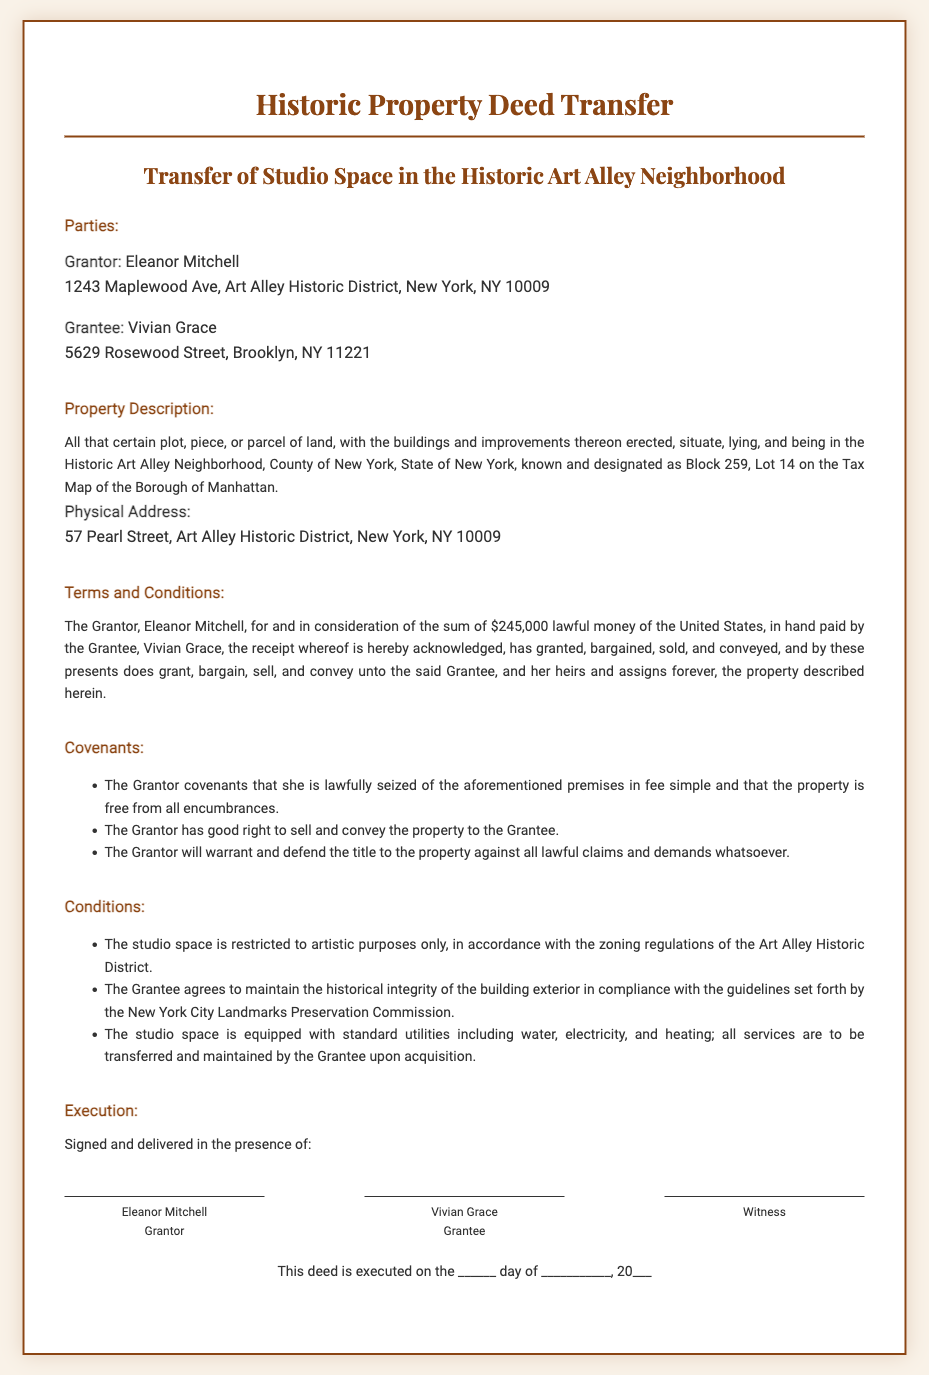What is the name of the Grantor? The Grantor is explicitly named in the document as Eleanor Mitchell.
Answer: Eleanor Mitchell What is the address of the Grantee? The address of the Grantee, Vivian Grace, is provided in the document.
Answer: 5629 Rosewood Street, Brooklyn, NY 11221 What is the purchase price of the property? The specific sum for the property is mentioned in the Terms and Conditions section.
Answer: $245,000 What is the physical address of the property? The physical address is stated clearly in the Property Description section.
Answer: 57 Pearl Street, Art Alley Historic District, New York, NY 10009 What is the property designation on the Tax Map? The document refers to the property designation in the Property Description section.
Answer: Block 259, Lot 14 What is one of the conditions regarding the use of the studio space? The Conditions section specifies the usage policy of the studio space.
Answer: Artistic purposes only Who must maintain the historical integrity of the building exterior? The document states this requirement regarding the Grantee's responsibilities.
Answer: Grantee What must the Grantor defend in relation to the property? The covenants outline what the Grantor will defend concerning the title of the property.
Answer: Title to the property What is the document type? This question relates to the classification of the document as described in the heading.
Answer: Deed 